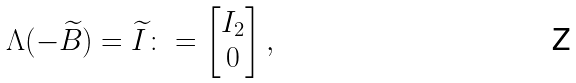<formula> <loc_0><loc_0><loc_500><loc_500>\Lambda ( - \widetilde { B } ) = \widetilde { I } \colon = \begin{bmatrix} I _ { 2 } \\ 0 \end{bmatrix} ,</formula> 